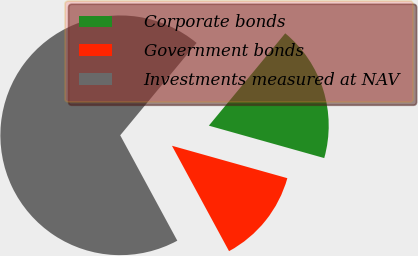Convert chart to OTSL. <chart><loc_0><loc_0><loc_500><loc_500><pie_chart><fcel>Corporate bonds<fcel>Government bonds<fcel>Investments measured at NAV<nl><fcel>18.36%<fcel>12.74%<fcel>68.9%<nl></chart> 